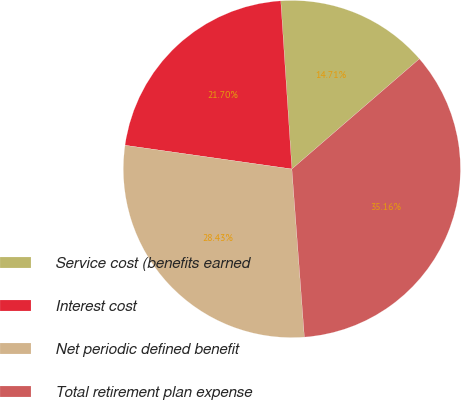Convert chart to OTSL. <chart><loc_0><loc_0><loc_500><loc_500><pie_chart><fcel>Service cost (benefits earned<fcel>Interest cost<fcel>Net periodic defined benefit<fcel>Total retirement plan expense<nl><fcel>14.71%<fcel>21.7%<fcel>28.43%<fcel>35.16%<nl></chart> 